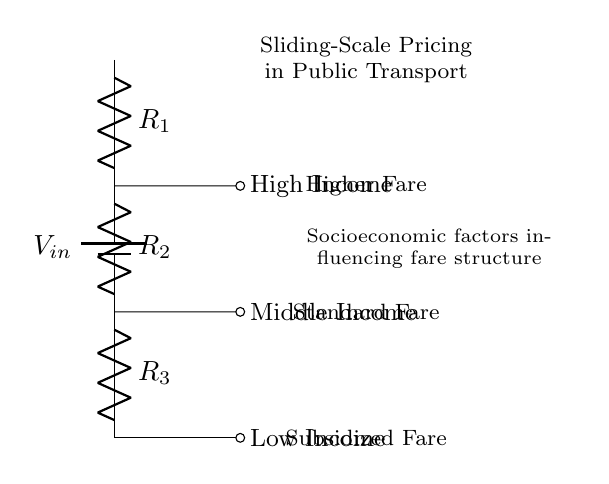What is the input voltage? The input voltage is indicated as \( V_{in} \) in the circuit diagram. It represents the total voltage supplied to the voltage divider circuit.
Answer: V_{in} How many resistors are present in the circuit? The circuit diagram shows three resistors, labelled \( R_1 \), \( R_2 \), and \( R_3 \). Each resistor contributes to the total voltage drop across the circuit.
Answer: 3 Which fare is associated with the highest income? The circuit diagram connects the high income node to the top resistor \( R_1 \), indicating that it is associated with the highest fare in the sliding scale pricing system.
Answer: Higher Fare What fare category is represented at the bottom of the circuit? The lowest point in the circuit corresponds to the output node where the subsidized fare is indicated. This fare category typically applies to low-income individuals.
Answer: Subsidized Fare What is the purpose of the voltage divider in this context? The purpose of the voltage divider is to create a sliding-scale pricing mechanism, allowing different fare amounts based on the socioeconomic status of the user, as indicated in the diagram.
Answer: Sliding-scale pricing Which resistor represents the middle fare? The middle fare is associated with the second resistor \( R_2 \) in the circuit, which splits the voltage associated with the middle income.
Answer: R_2 How does the arrangement of resistors affect fare pricing? The series arrangement of the resistors determines the voltage drop across each resistor, which directly corresponds to different fare categories, affecting the fare prices for high, middle, and low income users.
Answer: Voltage drop 